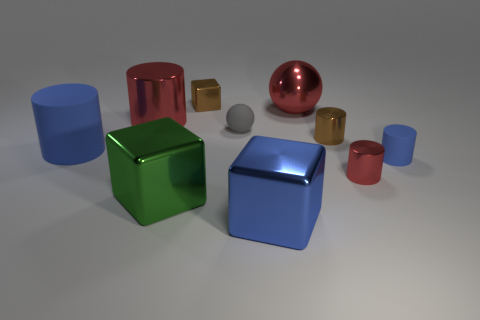How is the lighting affecting the appearance of the objects? The lighting in the image creates soft shadows on the right-hand side of the objects, suggesting a light source from the left. It also enhances their shininess, especially on the sides facing the light, and contributes to the reflection effects on the more reflective surfaces. 